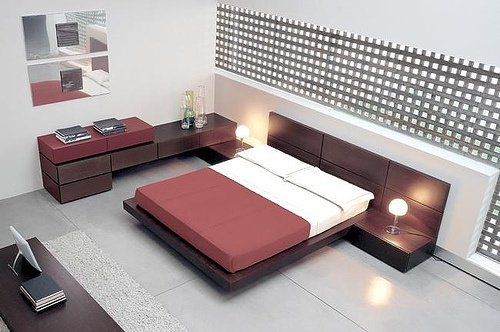Describe the objects in this image and their specific colors. I can see bed in lightgray, brown, white, and black tones, book in lightgray, gray, darkblue, and black tones, book in lightgray, black, gray, and darkgray tones, book in lightgray, gray, darkgray, and black tones, and book in lightgray, gray, darkgray, and black tones in this image. 